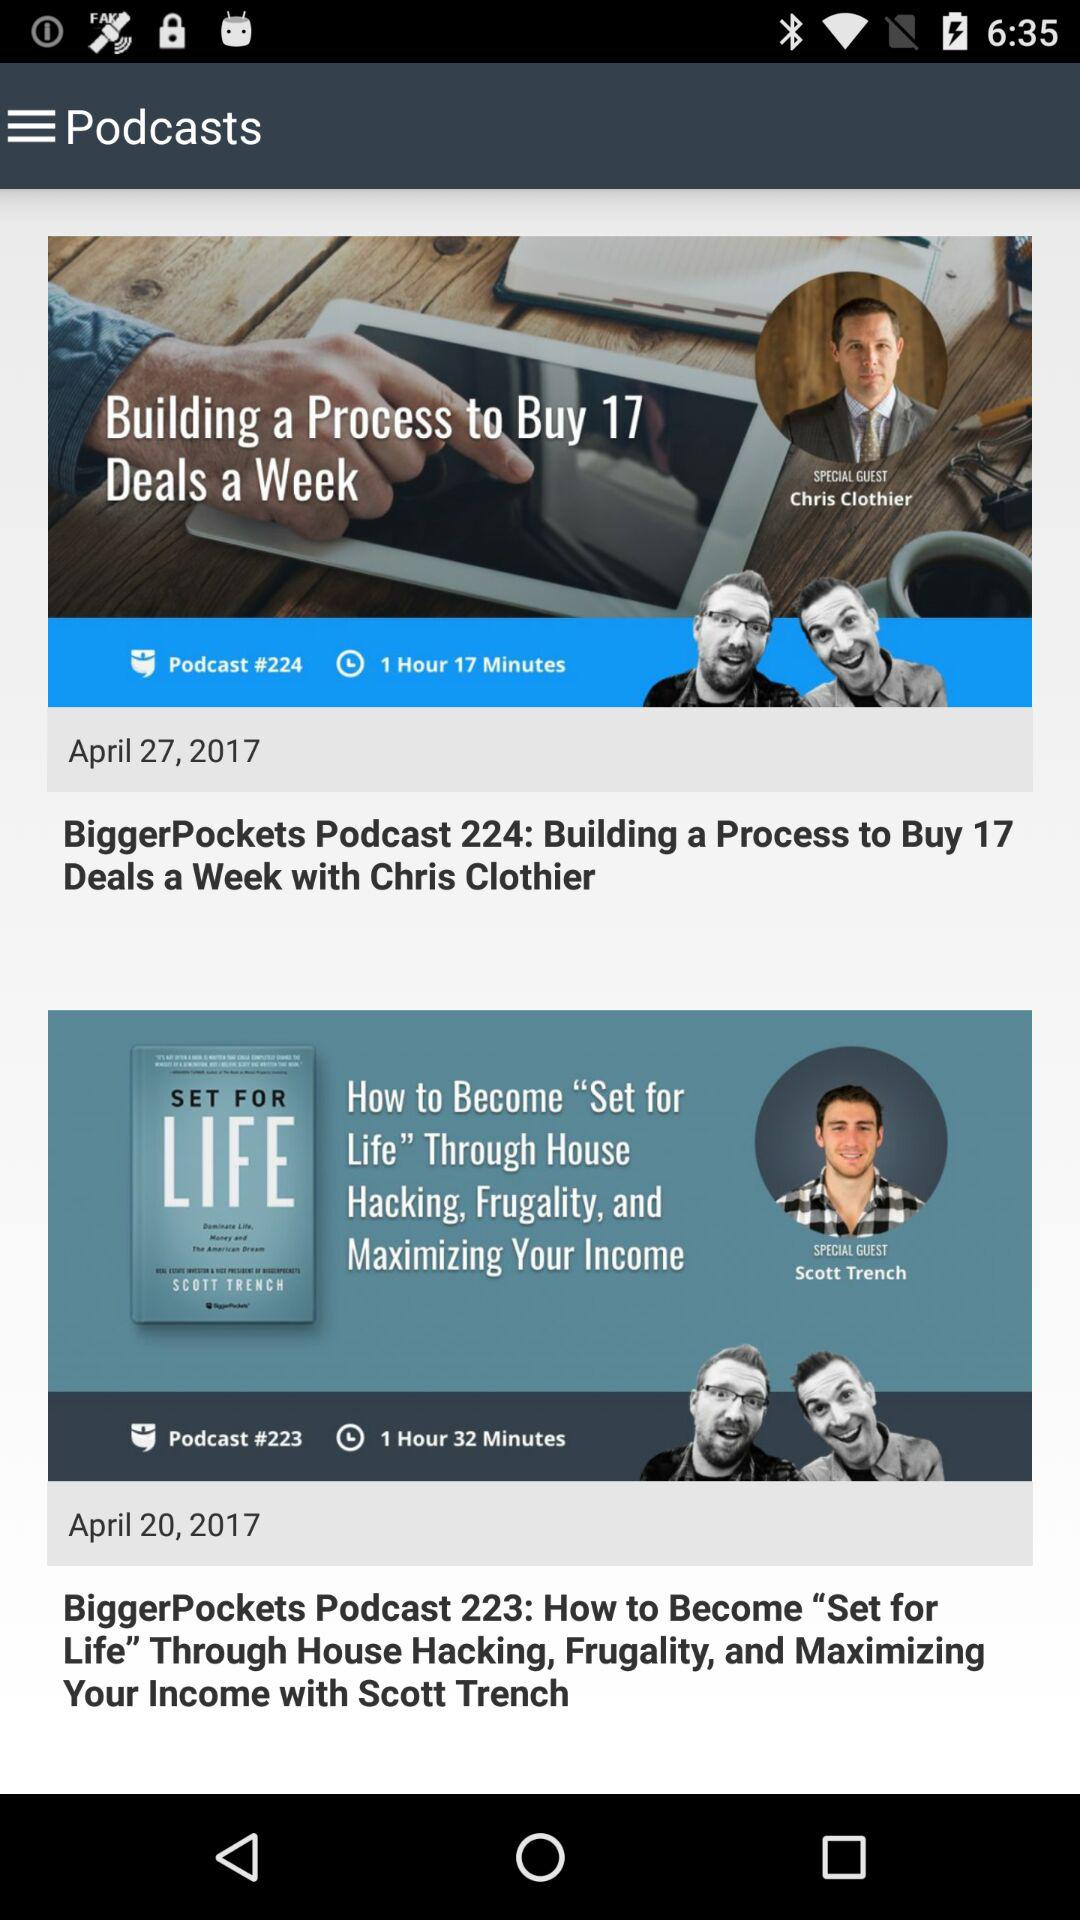What is the post of april 17?
When the provided information is insufficient, respond with <no answer>. <no answer> 